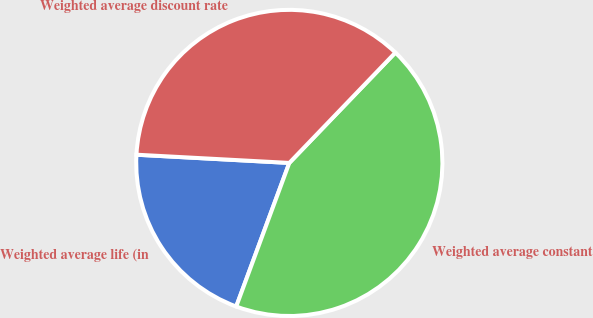<chart> <loc_0><loc_0><loc_500><loc_500><pie_chart><fcel>Weighted average life (in<fcel>Weighted average constant<fcel>Weighted average discount rate<nl><fcel>20.22%<fcel>43.45%<fcel>36.33%<nl></chart> 